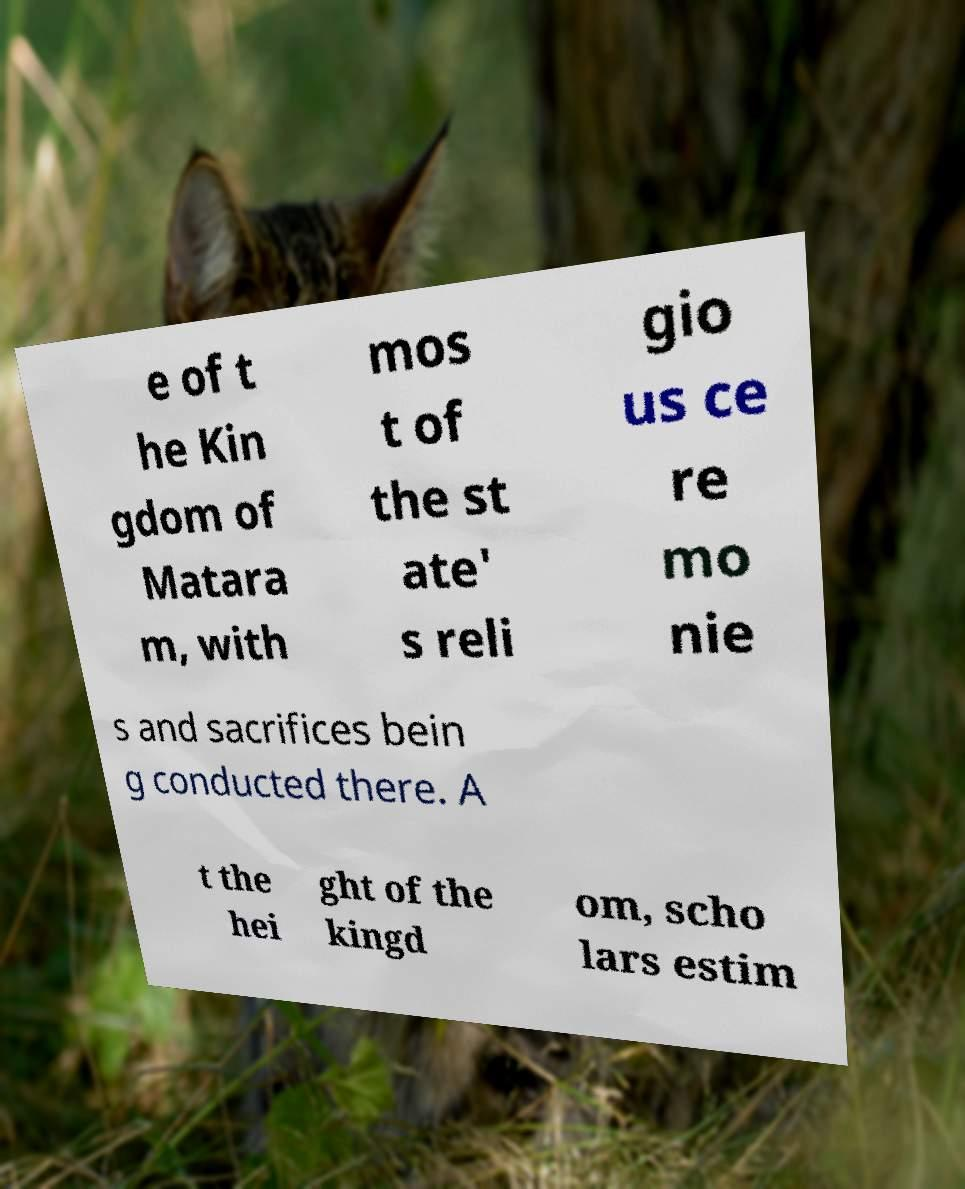Could you extract and type out the text from this image? e of t he Kin gdom of Matara m, with mos t of the st ate' s reli gio us ce re mo nie s and sacrifices bein g conducted there. A t the hei ght of the kingd om, scho lars estim 